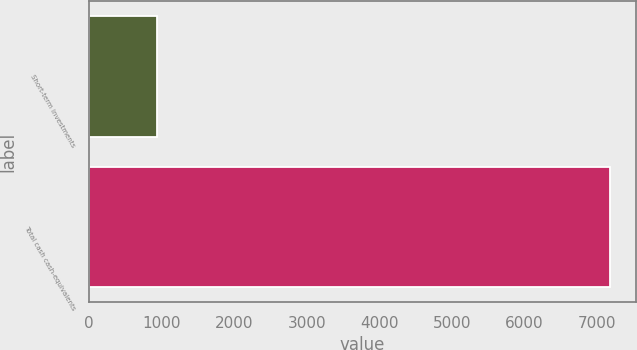Convert chart to OTSL. <chart><loc_0><loc_0><loc_500><loc_500><bar_chart><fcel>Short-term investments<fcel>Total cash cash-equivalents<nl><fcel>931<fcel>7174<nl></chart> 